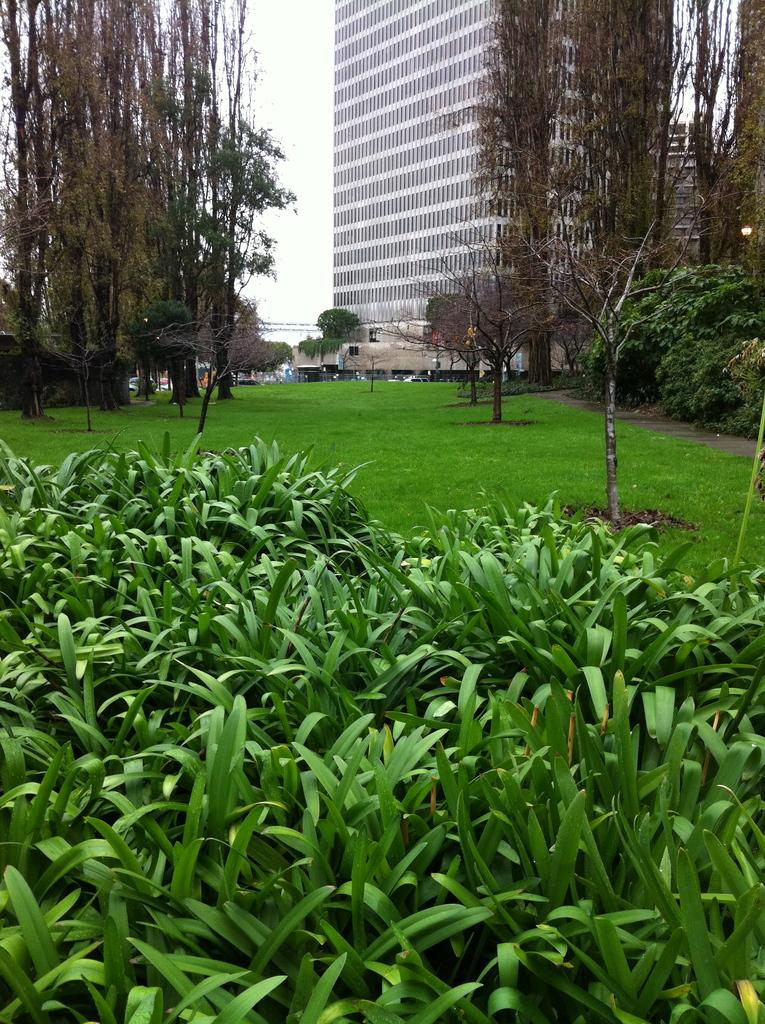What type of vegetation can be seen in the image? There are plants and trees in the image. What is the location of the trees in the image? The trees are on the ground in the image. What can be seen in the background of the image? There is a building and the sky visible in the background of the image. Can you describe the unspecified objects in the background of the image? Unfortunately, the facts provided do not specify the nature of the unspecified objects in the background. What type of sweater is being worn by the plant in the image? There are no people or animals wearing sweaters in the image, as it features plants, trees, a building, and the sky. 